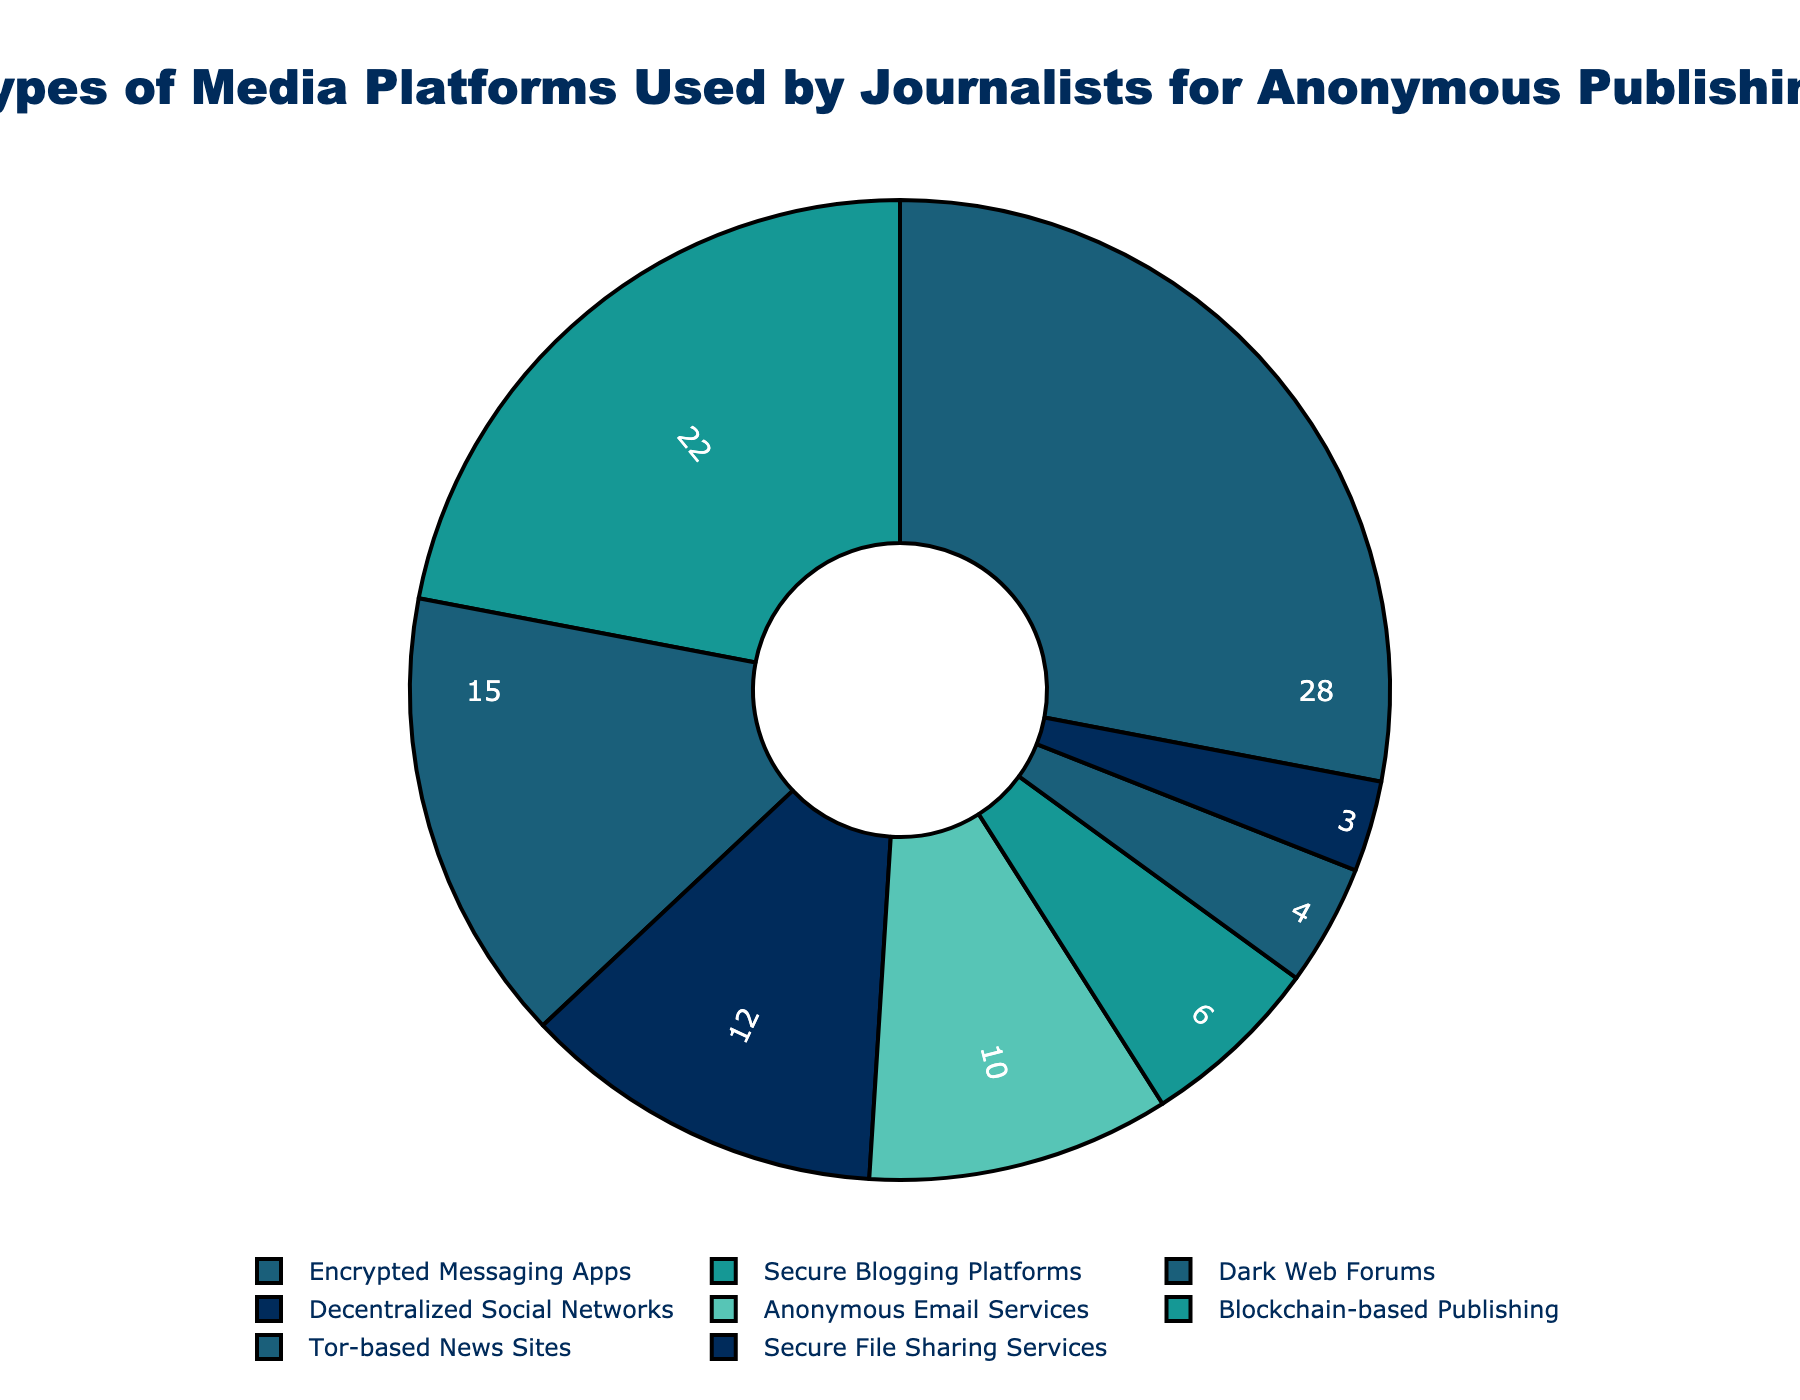Which platform has the highest percentage of use by journalists? According to the figure, "Encrypted Messaging Apps" account for the highest percentage of use by journalists, which is 28%.
Answer: Encrypted Messaging Apps Which platform is used more: Dark Web Forums or Anonymous Email Services? "Dark Web Forums" are used by 15% of journalists, whereas "Anonymous Email Services" are used by 10%. Since 15% is greater than 10%, "Dark Web Forums" are used more.
Answer: Dark Web Forums What is the combined percentage of journalists using Secure Blogging Platforms and Blockchain-based Publishing? Secure Blogging Platforms are used by 22% of journalists and Blockchain-based Publishing by 6%. The combined percentage is 22% + 6% = 28%.
Answer: 28% Which platform has the least percentage of use according to the figure? The platform with the smallest percentage of use is "Secure File Sharing Services," which accounts for 3% of journalists.
Answer: Secure File Sharing Services How much greater is the use of Decentralized Social Networks compared to Tor-based News Sites? Decentralized Social Networks are used by 12% of journalists, while Tor-based News Sites are used by 4%. The difference is 12% - 4% = 8%.
Answer: 8% Is the share of usage for Secure Blogging Platforms equal to the share of usage for Decentralized Social Networks and Tor-based News Sites combined? Secure Blogging Platforms account for 22% of use. Decentralized Social Networks and Tor-based News Sites combined are 12% + 4% = 16%, which is not equal to 22%.
Answer: No What is the average percentage of use for Tors-based News Sites, Secure File Sharing Services, and Blockchain-based Publishing platforms? Tor-based News Sites 4%, Secure File Sharing Services 3%, and Blockchain-based Publishing 6%. The average is (4 + 3 + 6) / 3 = 13 / 3 ≈ 4.33%.
Answer: 4.33% Which platforms together make up more than half of the total percentage of use? Encrypted Messaging Apps (28%) and Secure Blogging Platforms (22%) together total 28% + 22% = 50%.
Answer: Encrypted Messaging Apps, Secure Blogging Platforms 